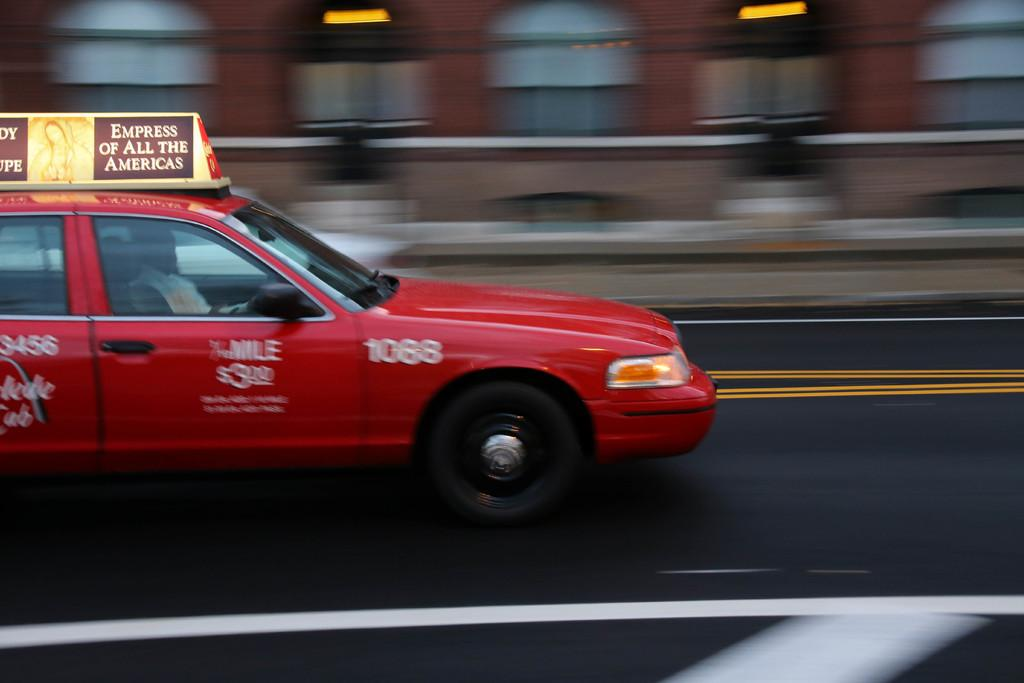<image>
Create a compact narrative representing the image presented. A red taxi driving with an ad for the empress of all the Americas on the top of their car. 